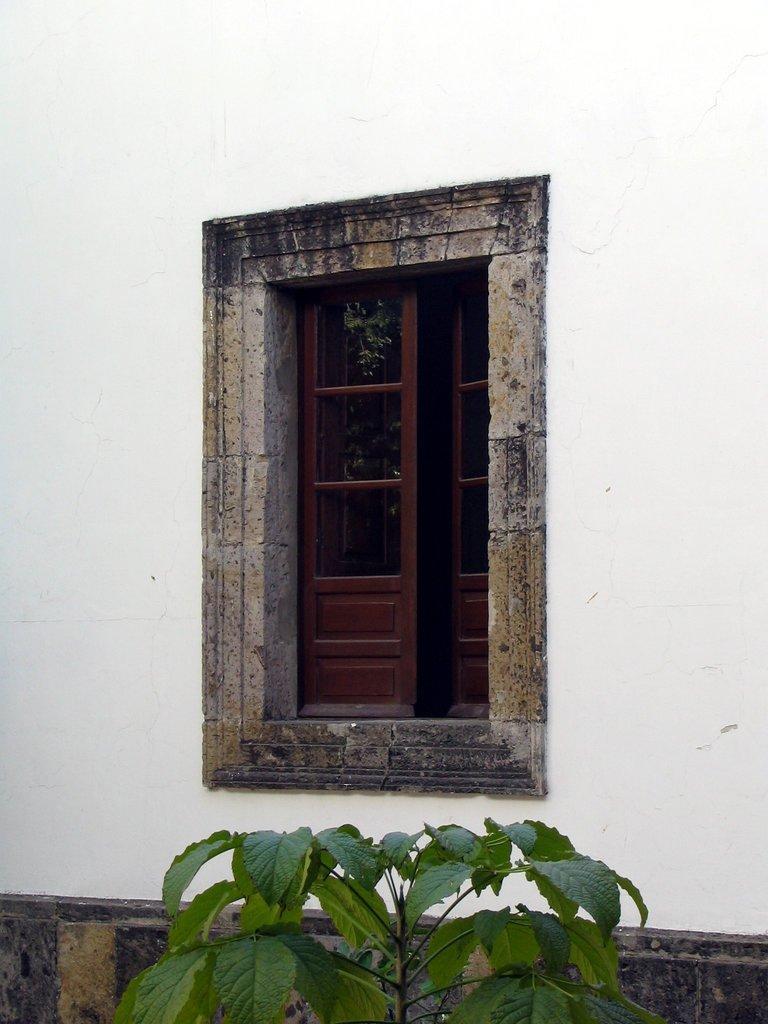Can you describe this image briefly? There are leaves of a plant at the bottom of this image. We can see a window and a wall in the middle of this image. 